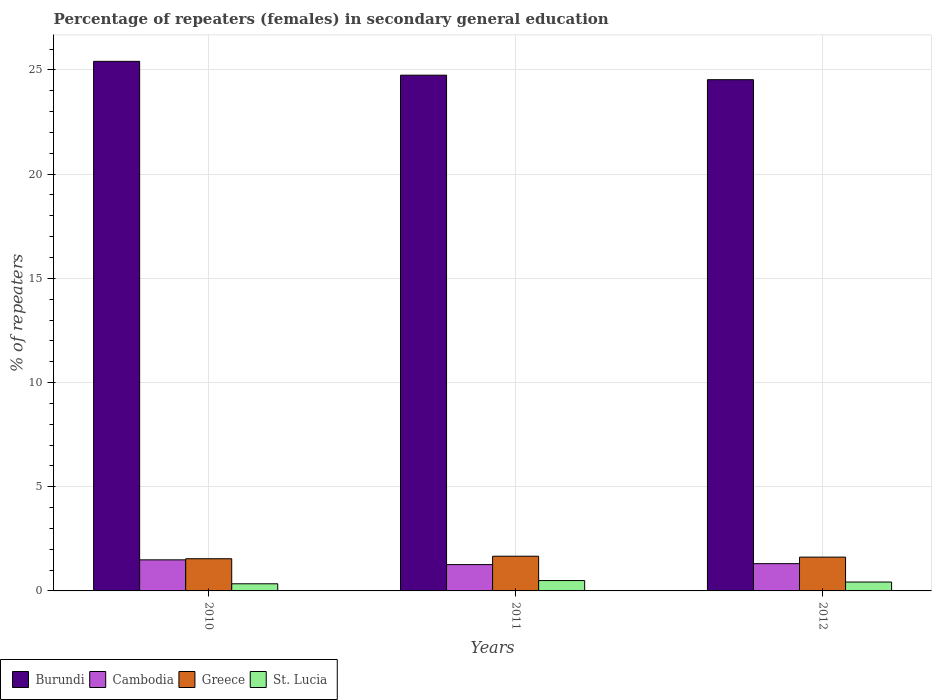How many bars are there on the 1st tick from the left?
Provide a succinct answer. 4. What is the label of the 1st group of bars from the left?
Provide a short and direct response. 2010. What is the percentage of female repeaters in Greece in 2011?
Ensure brevity in your answer.  1.67. Across all years, what is the maximum percentage of female repeaters in Cambodia?
Your response must be concise. 1.49. Across all years, what is the minimum percentage of female repeaters in Greece?
Offer a very short reply. 1.54. In which year was the percentage of female repeaters in Cambodia maximum?
Offer a terse response. 2010. What is the total percentage of female repeaters in St. Lucia in the graph?
Give a very brief answer. 1.27. What is the difference between the percentage of female repeaters in Greece in 2010 and that in 2012?
Give a very brief answer. -0.08. What is the difference between the percentage of female repeaters in Cambodia in 2010 and the percentage of female repeaters in St. Lucia in 2012?
Offer a terse response. 1.06. What is the average percentage of female repeaters in Cambodia per year?
Offer a terse response. 1.35. In the year 2012, what is the difference between the percentage of female repeaters in St. Lucia and percentage of female repeaters in Greece?
Ensure brevity in your answer.  -1.2. In how many years, is the percentage of female repeaters in Burundi greater than 11 %?
Ensure brevity in your answer.  3. What is the ratio of the percentage of female repeaters in Greece in 2010 to that in 2012?
Provide a short and direct response. 0.95. Is the difference between the percentage of female repeaters in St. Lucia in 2011 and 2012 greater than the difference between the percentage of female repeaters in Greece in 2011 and 2012?
Your response must be concise. Yes. What is the difference between the highest and the second highest percentage of female repeaters in St. Lucia?
Ensure brevity in your answer.  0.07. What is the difference between the highest and the lowest percentage of female repeaters in Cambodia?
Offer a very short reply. 0.23. In how many years, is the percentage of female repeaters in St. Lucia greater than the average percentage of female repeaters in St. Lucia taken over all years?
Provide a short and direct response. 2. What does the 2nd bar from the left in 2010 represents?
Your response must be concise. Cambodia. What does the 1st bar from the right in 2012 represents?
Offer a terse response. St. Lucia. Is it the case that in every year, the sum of the percentage of female repeaters in Greece and percentage of female repeaters in Cambodia is greater than the percentage of female repeaters in St. Lucia?
Provide a succinct answer. Yes. How many bars are there?
Provide a succinct answer. 12. Are all the bars in the graph horizontal?
Keep it short and to the point. No. How many years are there in the graph?
Your answer should be compact. 3. What is the difference between two consecutive major ticks on the Y-axis?
Your answer should be compact. 5. Are the values on the major ticks of Y-axis written in scientific E-notation?
Make the answer very short. No. Does the graph contain any zero values?
Provide a succinct answer. No. Does the graph contain grids?
Offer a very short reply. Yes. Where does the legend appear in the graph?
Your answer should be compact. Bottom left. How are the legend labels stacked?
Provide a succinct answer. Horizontal. What is the title of the graph?
Make the answer very short. Percentage of repeaters (females) in secondary general education. Does "Dominica" appear as one of the legend labels in the graph?
Ensure brevity in your answer.  No. What is the label or title of the Y-axis?
Your answer should be compact. % of repeaters. What is the % of repeaters of Burundi in 2010?
Provide a short and direct response. 25.41. What is the % of repeaters in Cambodia in 2010?
Ensure brevity in your answer.  1.49. What is the % of repeaters of Greece in 2010?
Provide a succinct answer. 1.54. What is the % of repeaters of St. Lucia in 2010?
Give a very brief answer. 0.34. What is the % of repeaters of Burundi in 2011?
Offer a very short reply. 24.75. What is the % of repeaters in Cambodia in 2011?
Provide a succinct answer. 1.26. What is the % of repeaters of Greece in 2011?
Offer a terse response. 1.67. What is the % of repeaters of St. Lucia in 2011?
Keep it short and to the point. 0.5. What is the % of repeaters of Burundi in 2012?
Provide a succinct answer. 24.53. What is the % of repeaters of Cambodia in 2012?
Give a very brief answer. 1.31. What is the % of repeaters in Greece in 2012?
Ensure brevity in your answer.  1.62. What is the % of repeaters of St. Lucia in 2012?
Keep it short and to the point. 0.43. Across all years, what is the maximum % of repeaters in Burundi?
Provide a short and direct response. 25.41. Across all years, what is the maximum % of repeaters in Cambodia?
Ensure brevity in your answer.  1.49. Across all years, what is the maximum % of repeaters in Greece?
Give a very brief answer. 1.67. Across all years, what is the maximum % of repeaters of St. Lucia?
Keep it short and to the point. 0.5. Across all years, what is the minimum % of repeaters in Burundi?
Provide a short and direct response. 24.53. Across all years, what is the minimum % of repeaters in Cambodia?
Give a very brief answer. 1.26. Across all years, what is the minimum % of repeaters in Greece?
Offer a very short reply. 1.54. Across all years, what is the minimum % of repeaters in St. Lucia?
Keep it short and to the point. 0.34. What is the total % of repeaters in Burundi in the graph?
Offer a very short reply. 74.69. What is the total % of repeaters in Cambodia in the graph?
Your answer should be very brief. 4.06. What is the total % of repeaters in Greece in the graph?
Ensure brevity in your answer.  4.83. What is the total % of repeaters in St. Lucia in the graph?
Your answer should be compact. 1.27. What is the difference between the % of repeaters of Burundi in 2010 and that in 2011?
Your answer should be compact. 0.66. What is the difference between the % of repeaters of Cambodia in 2010 and that in 2011?
Make the answer very short. 0.23. What is the difference between the % of repeaters in Greece in 2010 and that in 2011?
Provide a short and direct response. -0.12. What is the difference between the % of repeaters of St. Lucia in 2010 and that in 2011?
Offer a terse response. -0.16. What is the difference between the % of repeaters in Burundi in 2010 and that in 2012?
Make the answer very short. 0.88. What is the difference between the % of repeaters in Cambodia in 2010 and that in 2012?
Your answer should be compact. 0.18. What is the difference between the % of repeaters of Greece in 2010 and that in 2012?
Ensure brevity in your answer.  -0.08. What is the difference between the % of repeaters of St. Lucia in 2010 and that in 2012?
Provide a short and direct response. -0.08. What is the difference between the % of repeaters of Burundi in 2011 and that in 2012?
Your response must be concise. 0.22. What is the difference between the % of repeaters in Cambodia in 2011 and that in 2012?
Your response must be concise. -0.05. What is the difference between the % of repeaters of Greece in 2011 and that in 2012?
Keep it short and to the point. 0.04. What is the difference between the % of repeaters in St. Lucia in 2011 and that in 2012?
Provide a succinct answer. 0.07. What is the difference between the % of repeaters of Burundi in 2010 and the % of repeaters of Cambodia in 2011?
Offer a very short reply. 24.15. What is the difference between the % of repeaters in Burundi in 2010 and the % of repeaters in Greece in 2011?
Provide a short and direct response. 23.75. What is the difference between the % of repeaters in Burundi in 2010 and the % of repeaters in St. Lucia in 2011?
Provide a short and direct response. 24.91. What is the difference between the % of repeaters of Cambodia in 2010 and the % of repeaters of Greece in 2011?
Offer a very short reply. -0.17. What is the difference between the % of repeaters in Cambodia in 2010 and the % of repeaters in St. Lucia in 2011?
Ensure brevity in your answer.  0.99. What is the difference between the % of repeaters of Greece in 2010 and the % of repeaters of St. Lucia in 2011?
Offer a terse response. 1.05. What is the difference between the % of repeaters in Burundi in 2010 and the % of repeaters in Cambodia in 2012?
Offer a very short reply. 24.1. What is the difference between the % of repeaters in Burundi in 2010 and the % of repeaters in Greece in 2012?
Ensure brevity in your answer.  23.79. What is the difference between the % of repeaters of Burundi in 2010 and the % of repeaters of St. Lucia in 2012?
Keep it short and to the point. 24.99. What is the difference between the % of repeaters in Cambodia in 2010 and the % of repeaters in Greece in 2012?
Your answer should be very brief. -0.13. What is the difference between the % of repeaters of Cambodia in 2010 and the % of repeaters of St. Lucia in 2012?
Provide a succinct answer. 1.06. What is the difference between the % of repeaters in Greece in 2010 and the % of repeaters in St. Lucia in 2012?
Your answer should be compact. 1.12. What is the difference between the % of repeaters in Burundi in 2011 and the % of repeaters in Cambodia in 2012?
Your response must be concise. 23.44. What is the difference between the % of repeaters of Burundi in 2011 and the % of repeaters of Greece in 2012?
Provide a succinct answer. 23.13. What is the difference between the % of repeaters of Burundi in 2011 and the % of repeaters of St. Lucia in 2012?
Your answer should be very brief. 24.32. What is the difference between the % of repeaters of Cambodia in 2011 and the % of repeaters of Greece in 2012?
Keep it short and to the point. -0.36. What is the difference between the % of repeaters in Cambodia in 2011 and the % of repeaters in St. Lucia in 2012?
Offer a terse response. 0.84. What is the difference between the % of repeaters of Greece in 2011 and the % of repeaters of St. Lucia in 2012?
Ensure brevity in your answer.  1.24. What is the average % of repeaters in Burundi per year?
Make the answer very short. 24.9. What is the average % of repeaters of Cambodia per year?
Your answer should be very brief. 1.35. What is the average % of repeaters in Greece per year?
Your answer should be compact. 1.61. What is the average % of repeaters of St. Lucia per year?
Provide a succinct answer. 0.42. In the year 2010, what is the difference between the % of repeaters in Burundi and % of repeaters in Cambodia?
Ensure brevity in your answer.  23.92. In the year 2010, what is the difference between the % of repeaters in Burundi and % of repeaters in Greece?
Make the answer very short. 23.87. In the year 2010, what is the difference between the % of repeaters of Burundi and % of repeaters of St. Lucia?
Keep it short and to the point. 25.07. In the year 2010, what is the difference between the % of repeaters in Cambodia and % of repeaters in Greece?
Offer a very short reply. -0.05. In the year 2010, what is the difference between the % of repeaters of Cambodia and % of repeaters of St. Lucia?
Ensure brevity in your answer.  1.15. In the year 2010, what is the difference between the % of repeaters in Greece and % of repeaters in St. Lucia?
Keep it short and to the point. 1.2. In the year 2011, what is the difference between the % of repeaters of Burundi and % of repeaters of Cambodia?
Your answer should be compact. 23.49. In the year 2011, what is the difference between the % of repeaters of Burundi and % of repeaters of Greece?
Offer a terse response. 23.08. In the year 2011, what is the difference between the % of repeaters in Burundi and % of repeaters in St. Lucia?
Provide a succinct answer. 24.25. In the year 2011, what is the difference between the % of repeaters of Cambodia and % of repeaters of Greece?
Provide a succinct answer. -0.4. In the year 2011, what is the difference between the % of repeaters in Cambodia and % of repeaters in St. Lucia?
Your answer should be very brief. 0.77. In the year 2011, what is the difference between the % of repeaters of Greece and % of repeaters of St. Lucia?
Offer a terse response. 1.17. In the year 2012, what is the difference between the % of repeaters in Burundi and % of repeaters in Cambodia?
Keep it short and to the point. 23.22. In the year 2012, what is the difference between the % of repeaters of Burundi and % of repeaters of Greece?
Provide a succinct answer. 22.91. In the year 2012, what is the difference between the % of repeaters of Burundi and % of repeaters of St. Lucia?
Your answer should be very brief. 24.11. In the year 2012, what is the difference between the % of repeaters in Cambodia and % of repeaters in Greece?
Give a very brief answer. -0.31. In the year 2012, what is the difference between the % of repeaters of Cambodia and % of repeaters of St. Lucia?
Your answer should be very brief. 0.88. In the year 2012, what is the difference between the % of repeaters in Greece and % of repeaters in St. Lucia?
Ensure brevity in your answer.  1.2. What is the ratio of the % of repeaters in Burundi in 2010 to that in 2011?
Offer a terse response. 1.03. What is the ratio of the % of repeaters in Cambodia in 2010 to that in 2011?
Ensure brevity in your answer.  1.18. What is the ratio of the % of repeaters in Greece in 2010 to that in 2011?
Offer a terse response. 0.93. What is the ratio of the % of repeaters of St. Lucia in 2010 to that in 2011?
Provide a short and direct response. 0.69. What is the ratio of the % of repeaters in Burundi in 2010 to that in 2012?
Offer a very short reply. 1.04. What is the ratio of the % of repeaters in Cambodia in 2010 to that in 2012?
Offer a very short reply. 1.14. What is the ratio of the % of repeaters in Greece in 2010 to that in 2012?
Provide a succinct answer. 0.95. What is the ratio of the % of repeaters of St. Lucia in 2010 to that in 2012?
Provide a short and direct response. 0.8. What is the ratio of the % of repeaters of Burundi in 2011 to that in 2012?
Offer a very short reply. 1.01. What is the ratio of the % of repeaters of Cambodia in 2011 to that in 2012?
Provide a succinct answer. 0.97. What is the ratio of the % of repeaters of Greece in 2011 to that in 2012?
Provide a succinct answer. 1.03. What is the ratio of the % of repeaters in St. Lucia in 2011 to that in 2012?
Your answer should be very brief. 1.17. What is the difference between the highest and the second highest % of repeaters in Burundi?
Provide a short and direct response. 0.66. What is the difference between the highest and the second highest % of repeaters of Cambodia?
Offer a very short reply. 0.18. What is the difference between the highest and the second highest % of repeaters of Greece?
Offer a terse response. 0.04. What is the difference between the highest and the second highest % of repeaters in St. Lucia?
Your response must be concise. 0.07. What is the difference between the highest and the lowest % of repeaters in Burundi?
Make the answer very short. 0.88. What is the difference between the highest and the lowest % of repeaters of Cambodia?
Your answer should be very brief. 0.23. What is the difference between the highest and the lowest % of repeaters in Greece?
Give a very brief answer. 0.12. What is the difference between the highest and the lowest % of repeaters of St. Lucia?
Keep it short and to the point. 0.16. 